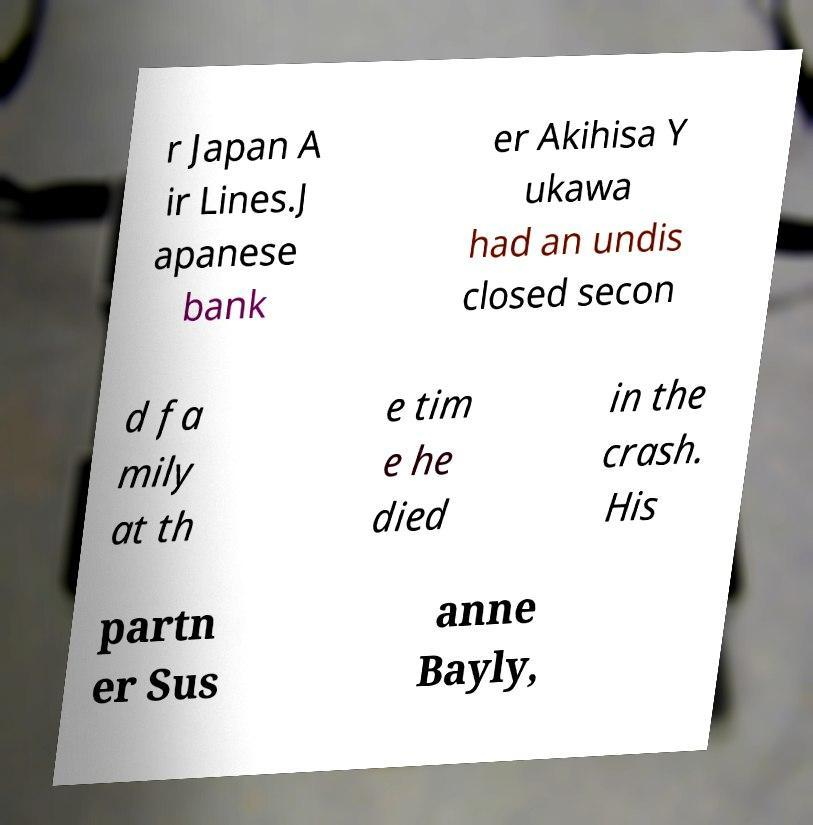There's text embedded in this image that I need extracted. Can you transcribe it verbatim? r Japan A ir Lines.J apanese bank er Akihisa Y ukawa had an undis closed secon d fa mily at th e tim e he died in the crash. His partn er Sus anne Bayly, 